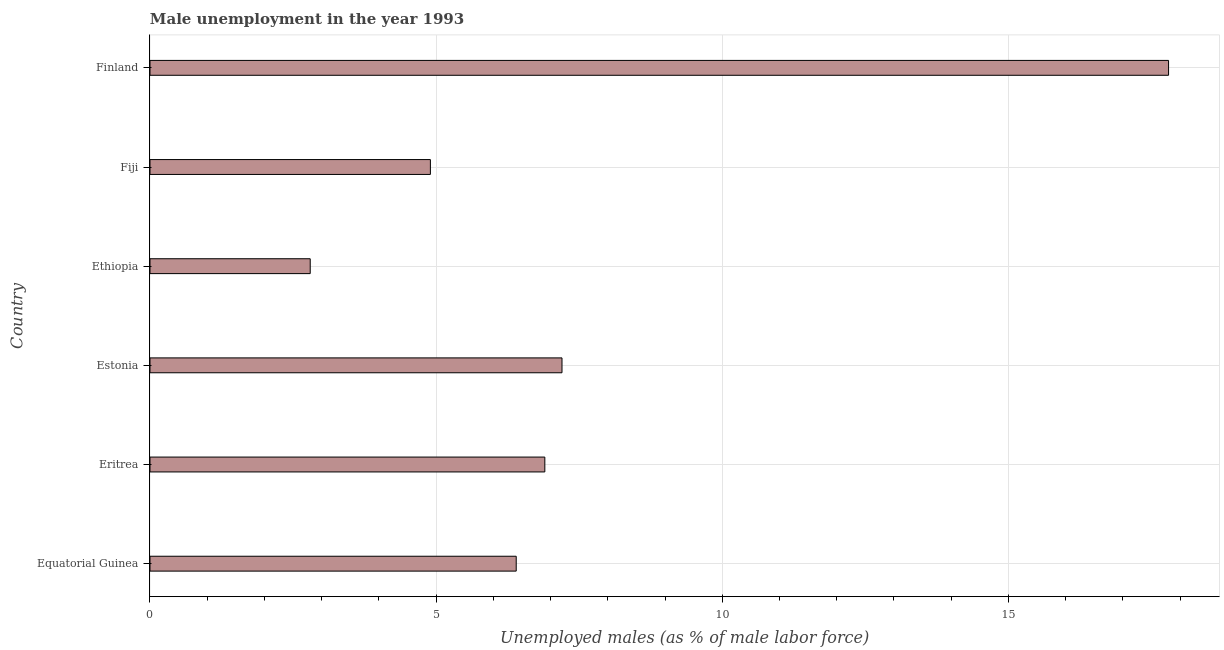Does the graph contain grids?
Give a very brief answer. Yes. What is the title of the graph?
Your answer should be compact. Male unemployment in the year 1993. What is the label or title of the X-axis?
Give a very brief answer. Unemployed males (as % of male labor force). What is the unemployed males population in Estonia?
Provide a succinct answer. 7.2. Across all countries, what is the maximum unemployed males population?
Provide a succinct answer. 17.8. Across all countries, what is the minimum unemployed males population?
Your response must be concise. 2.8. In which country was the unemployed males population minimum?
Your answer should be very brief. Ethiopia. What is the sum of the unemployed males population?
Ensure brevity in your answer.  46. What is the difference between the unemployed males population in Ethiopia and Fiji?
Provide a short and direct response. -2.1. What is the average unemployed males population per country?
Provide a short and direct response. 7.67. What is the median unemployed males population?
Offer a very short reply. 6.65. What is the ratio of the unemployed males population in Equatorial Guinea to that in Finland?
Give a very brief answer. 0.36. Is the difference between the unemployed males population in Ethiopia and Fiji greater than the difference between any two countries?
Provide a short and direct response. No. What is the difference between the highest and the lowest unemployed males population?
Offer a terse response. 15. What is the difference between two consecutive major ticks on the X-axis?
Keep it short and to the point. 5. What is the Unemployed males (as % of male labor force) of Equatorial Guinea?
Offer a terse response. 6.4. What is the Unemployed males (as % of male labor force) of Eritrea?
Your answer should be very brief. 6.9. What is the Unemployed males (as % of male labor force) in Estonia?
Offer a very short reply. 7.2. What is the Unemployed males (as % of male labor force) of Ethiopia?
Your response must be concise. 2.8. What is the Unemployed males (as % of male labor force) of Fiji?
Make the answer very short. 4.9. What is the Unemployed males (as % of male labor force) in Finland?
Keep it short and to the point. 17.8. What is the difference between the Unemployed males (as % of male labor force) in Equatorial Guinea and Eritrea?
Offer a terse response. -0.5. What is the difference between the Unemployed males (as % of male labor force) in Equatorial Guinea and Ethiopia?
Make the answer very short. 3.6. What is the difference between the Unemployed males (as % of male labor force) in Eritrea and Ethiopia?
Ensure brevity in your answer.  4.1. What is the difference between the Unemployed males (as % of male labor force) in Eritrea and Fiji?
Provide a short and direct response. 2. What is the difference between the Unemployed males (as % of male labor force) in Estonia and Ethiopia?
Your response must be concise. 4.4. What is the difference between the Unemployed males (as % of male labor force) in Fiji and Finland?
Your response must be concise. -12.9. What is the ratio of the Unemployed males (as % of male labor force) in Equatorial Guinea to that in Eritrea?
Ensure brevity in your answer.  0.93. What is the ratio of the Unemployed males (as % of male labor force) in Equatorial Guinea to that in Estonia?
Offer a terse response. 0.89. What is the ratio of the Unemployed males (as % of male labor force) in Equatorial Guinea to that in Ethiopia?
Make the answer very short. 2.29. What is the ratio of the Unemployed males (as % of male labor force) in Equatorial Guinea to that in Fiji?
Provide a short and direct response. 1.31. What is the ratio of the Unemployed males (as % of male labor force) in Equatorial Guinea to that in Finland?
Ensure brevity in your answer.  0.36. What is the ratio of the Unemployed males (as % of male labor force) in Eritrea to that in Estonia?
Ensure brevity in your answer.  0.96. What is the ratio of the Unemployed males (as % of male labor force) in Eritrea to that in Ethiopia?
Offer a very short reply. 2.46. What is the ratio of the Unemployed males (as % of male labor force) in Eritrea to that in Fiji?
Offer a terse response. 1.41. What is the ratio of the Unemployed males (as % of male labor force) in Eritrea to that in Finland?
Give a very brief answer. 0.39. What is the ratio of the Unemployed males (as % of male labor force) in Estonia to that in Ethiopia?
Offer a terse response. 2.57. What is the ratio of the Unemployed males (as % of male labor force) in Estonia to that in Fiji?
Keep it short and to the point. 1.47. What is the ratio of the Unemployed males (as % of male labor force) in Estonia to that in Finland?
Provide a succinct answer. 0.4. What is the ratio of the Unemployed males (as % of male labor force) in Ethiopia to that in Fiji?
Give a very brief answer. 0.57. What is the ratio of the Unemployed males (as % of male labor force) in Ethiopia to that in Finland?
Your response must be concise. 0.16. What is the ratio of the Unemployed males (as % of male labor force) in Fiji to that in Finland?
Provide a short and direct response. 0.28. 